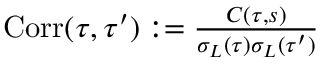Convert formula to latex. <formula><loc_0><loc_0><loc_500><loc_500>\begin{array} { r } { C o r r ( \tau , \tau ^ { \prime } ) \colon = \frac { C ( \tau , s ) } { \sigma _ { L } ( \tau ) \sigma _ { L } ( \tau ^ { \prime } ) } } \end{array}</formula> 